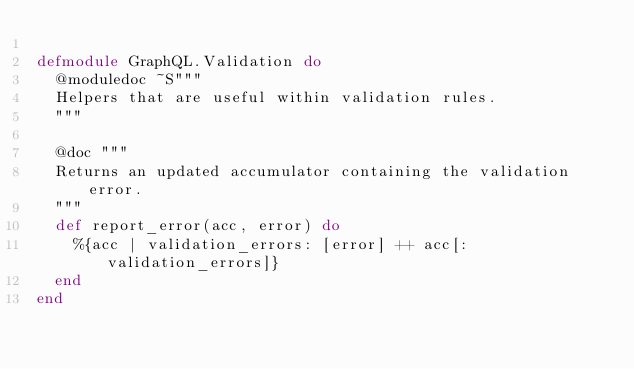Convert code to text. <code><loc_0><loc_0><loc_500><loc_500><_Elixir_>
defmodule GraphQL.Validation do
  @moduledoc ~S"""
  Helpers that are useful within validation rules.
  """

  @doc """
  Returns an updated accumulator containing the validation error.
  """
  def report_error(acc, error) do
    %{acc | validation_errors: [error] ++ acc[:validation_errors]}
  end
end
</code> 